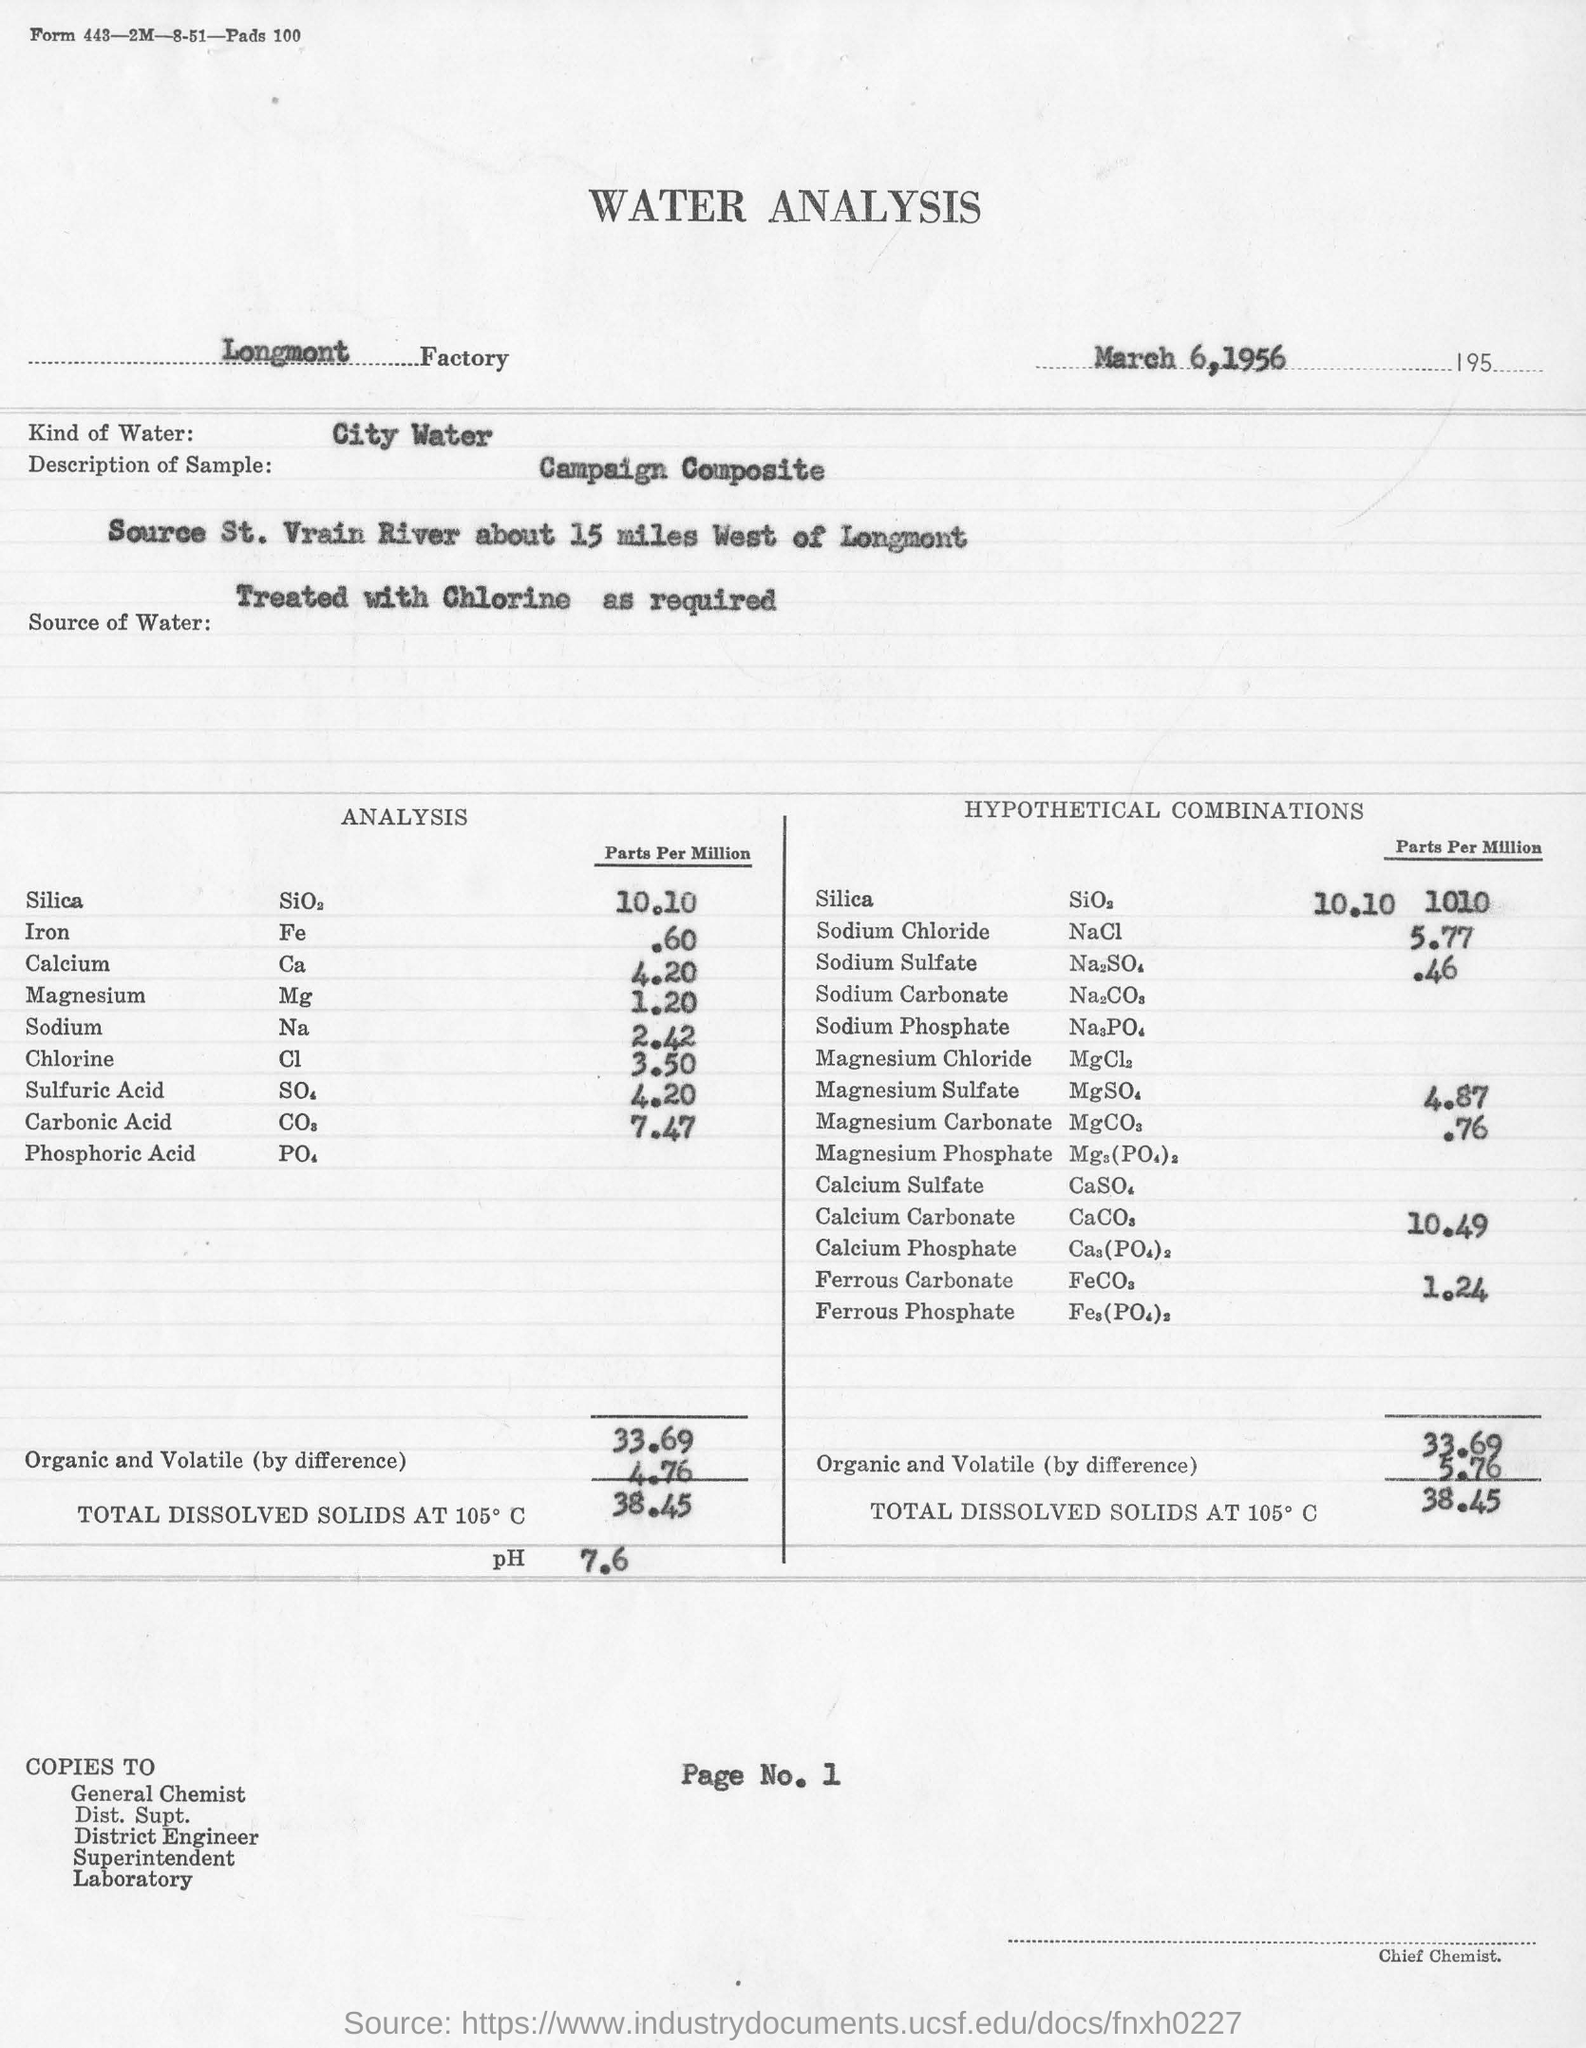Identify some key points in this picture. The parts per million analysis for sodium is 2.42 and this value represents the concentration of sodium in a substance. Chlorine is a chemical element with the symbol Cl and the atomic number 17. It is a green-yellow, highly reactive gas that is commonly used as a disinfectant and a chemical precursor in the production of various compounds. The factory name is Longmont. The analysis for chlorine using the parts per million method yielded a result of 3.50, indicating the presence of chlorine in the sample at a concentration of 3.50 parts per million. The date mentioned in the document is March 6, 1956. 